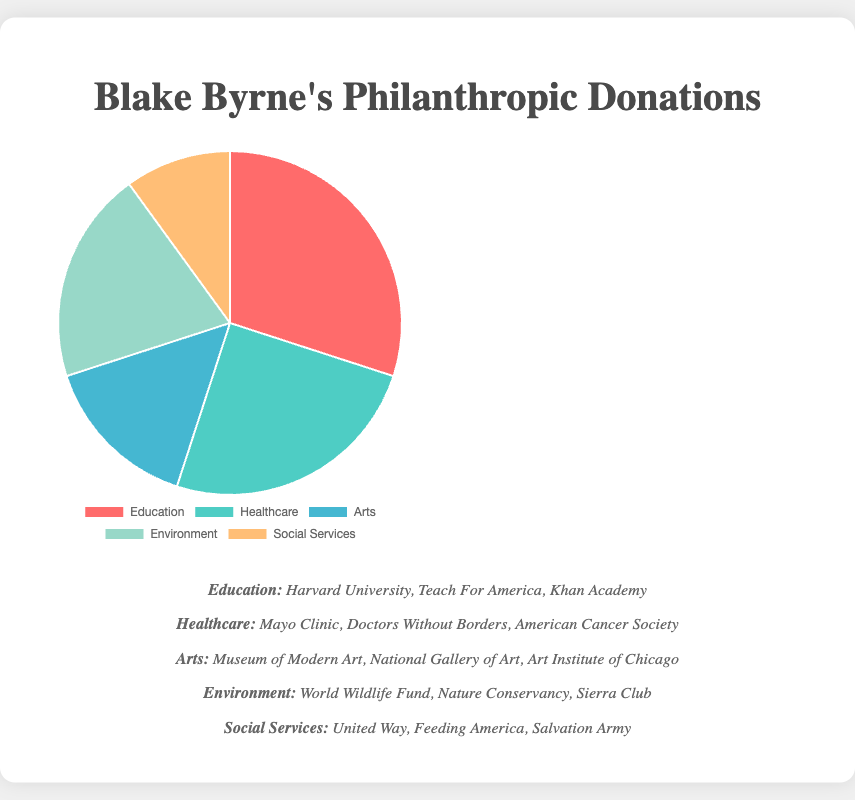What fields receive exactly 20% of philanthropic donations? Look at the pie chart and identify any field that is labeled with 20%. The "Environment" field shows a percentage of 20%.
Answer: Environment How much more funding is allocated to Healthcare compared to Social Services? Identify the percentages for both Healthcare and Social Services from the chart. Healthcare receives 25%, and Social Services receives 10%. Subtract 10% from 25% to find the difference: 25% - 10% = 15%.
Answer: 15% Which sector receives the highest allocation of philanthropic donations? Look for the sector with the largest percentage on the pie chart. The largest segment of the pie chart is for Education at 30%.
Answer: Education What is the cumulative percentage for donations to Education and Arts? Sum the percentages allocated to Education and Arts. Education has 30%, and Arts has 15%. Adding these together gives 30% + 15% = 45%.
Answer: 45% Is the amount donated to Environment greater than that to Arts? Compare the percentages of donations to Environment and Arts. Environment receives 20%, while Arts receives 15%. Since 20% is greater than 15%, the answer is yes.
Answer: Yes Which sectors combined make up exactly half of the total donations? Identify sectors whose percentages add up to 50%. Checking the pie chart, Education (30%) and Environment (20%) sum to 50%.
Answer: Education and Environment What is the difference in percentage between the fields with the highest and lowest donations? Identify the highest and lowest percentages on the pie chart. The highest is Education at 30%, and the lowest is Social Services at 10%. Subtract 10% from 30%: 30% - 10% = 20%.
Answer: 20% If the total donations amount to $1,000,000, how much is allocated to Healthcare? Calculate the amount by finding 25% of $1,000,000. This is done by multiplying: (25/100) * 1,000,000 = 250,000.
Answer: $250,000 Based on the given chart, what is more prevalent, funding for Environment or Arts, and by how much? Locate the percentages for Environment and Arts. Environment receives 20%, and Arts receives 15%. Subtract 15% from 20% to find the difference: 20% - 15% = 5%. Environment is more prevalent by 5%.
Answer: Environment by 5% 